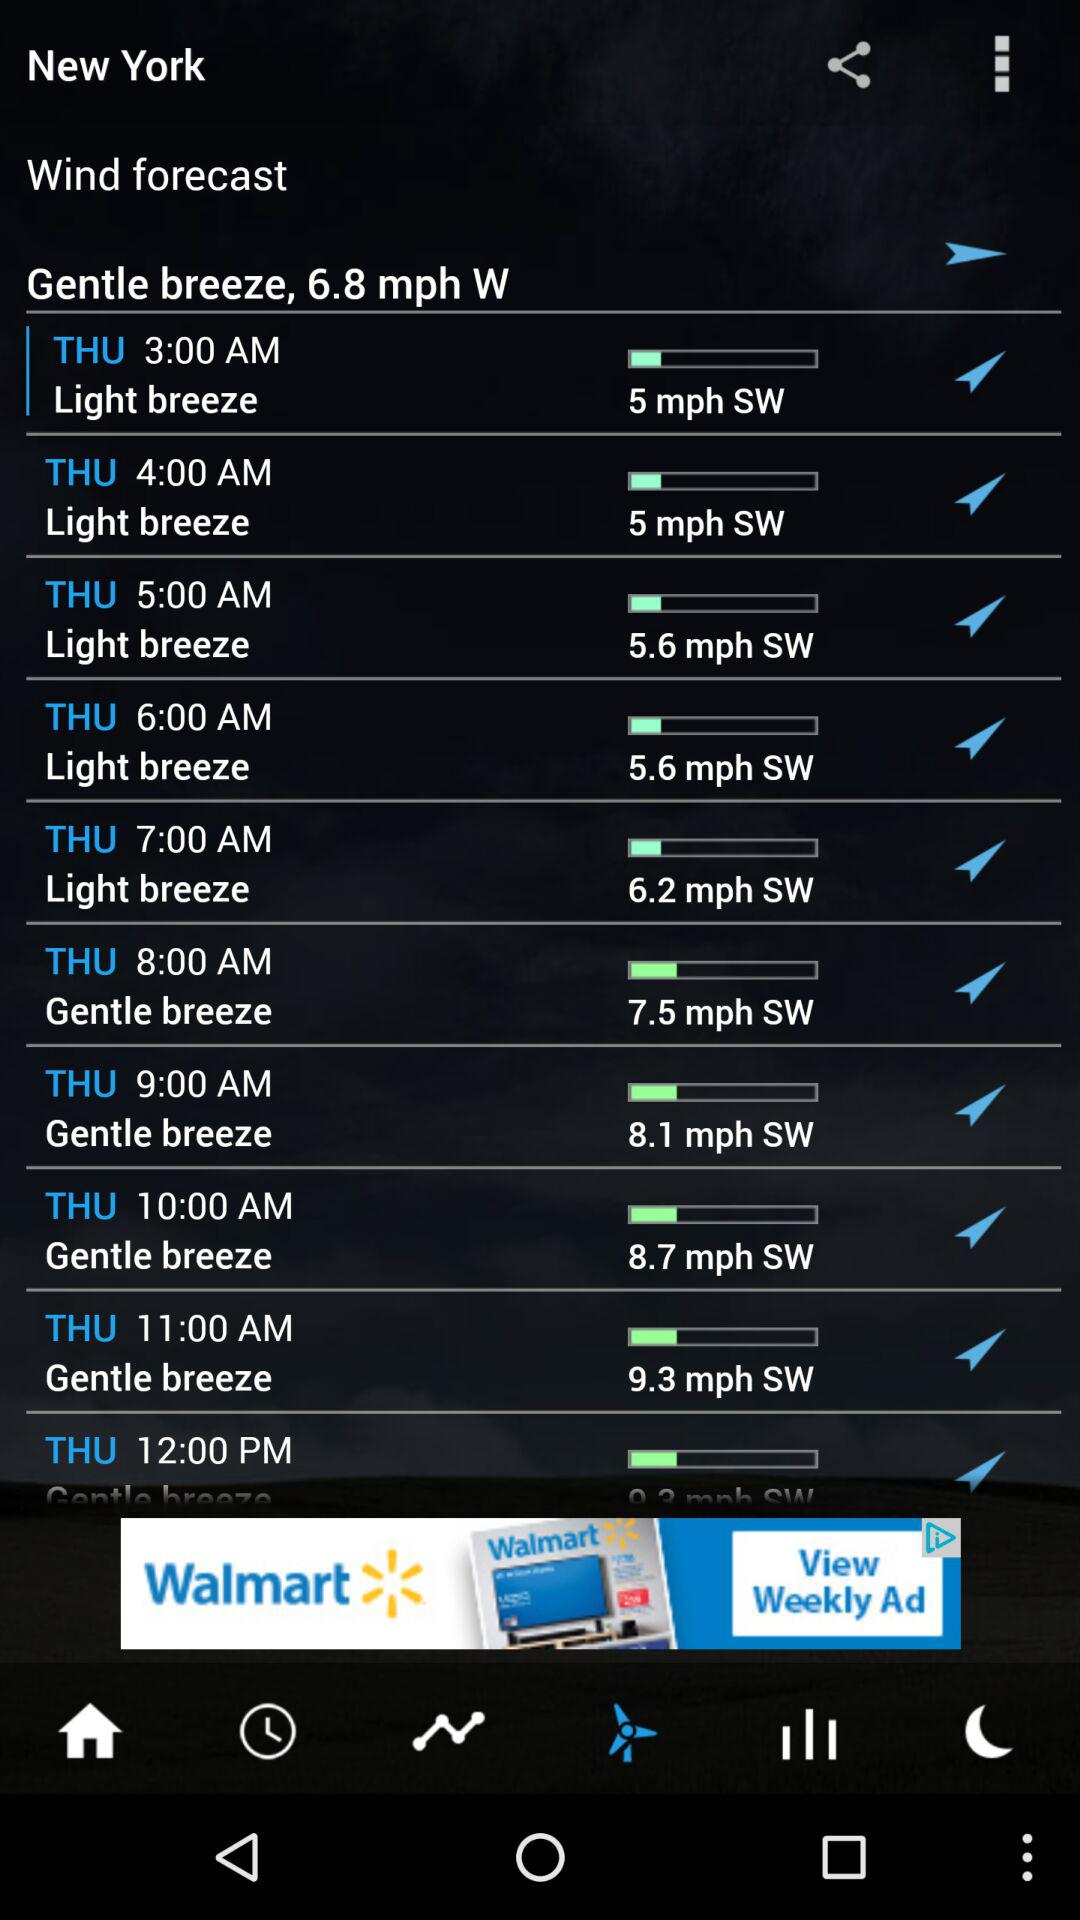What is the breeze going on Thursday at 11:00 am? It is "Gentle breeze". 